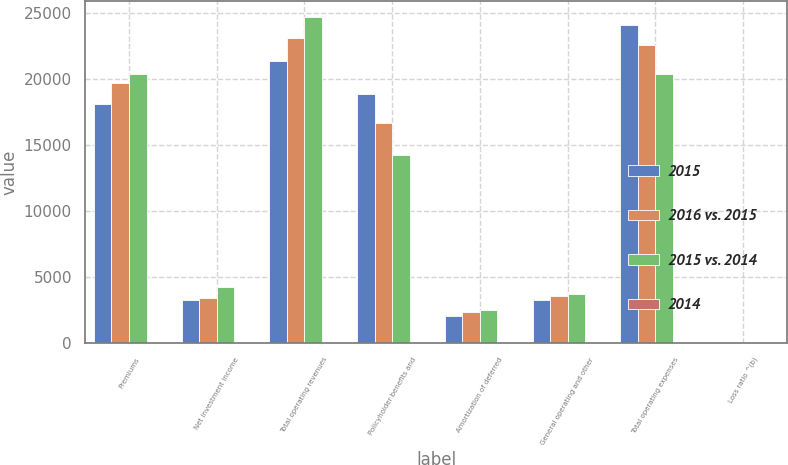Convert chart. <chart><loc_0><loc_0><loc_500><loc_500><stacked_bar_chart><ecel><fcel>Premiums<fcel>Net investment income<fcel>Total operating revenues<fcel>Policyholder benefits and<fcel>Amortization of deferred<fcel>General operating and other<fcel>Total operating expenses<fcel>Loss ratio ^(b)<nl><fcel>2015<fcel>18100<fcel>3268<fcel>21368<fcel>18828<fcel>2049<fcel>3226<fcel>24103<fcel>104<nl><fcel>2016 vs. 2015<fcel>19715<fcel>3421<fcel>23136<fcel>16660<fcel>2349<fcel>3562<fcel>22571<fcel>84.5<nl><fcel>2015 vs. 2014<fcel>20407<fcel>4255<fcel>24662<fcel>14226<fcel>2497<fcel>3692<fcel>20415<fcel>69.7<nl><fcel>2014<fcel>8<fcel>4<fcel>8<fcel>13<fcel>13<fcel>9<fcel>7<fcel>19.5<nl></chart> 